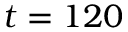<formula> <loc_0><loc_0><loc_500><loc_500>t = 1 2 0</formula> 